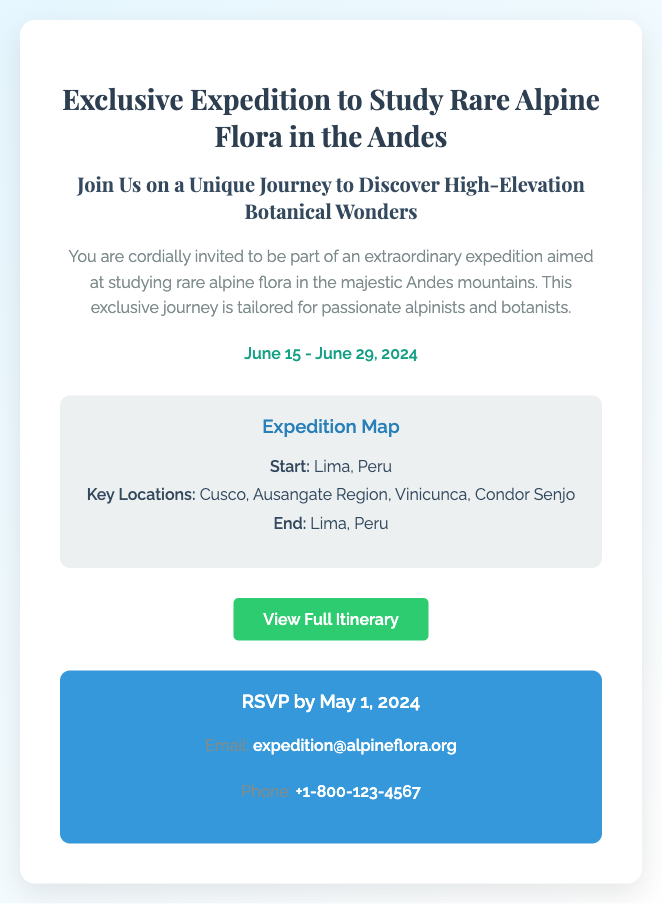What is the expedition date? The dates mentioned for the expedition are from June 15 to June 29, 2024.
Answer: June 15 - June 29, 2024 Where does the expedition start? The starting point of the expedition is listed as Lima, Peru.
Answer: Lima, Peru What is one key location included in the expedition? One of the key locations mentioned in the document is Vinicunca.
Answer: Vinicunca What is the RSVP deadline? The RSVP deadline specified in the document is May 1, 2024.
Answer: May 1, 2024 How can participants contact the expedition organizers? The document provides an email and phone number for contact, which are the means of communication available to the participants.
Answer: expedition@alpineflora.org 